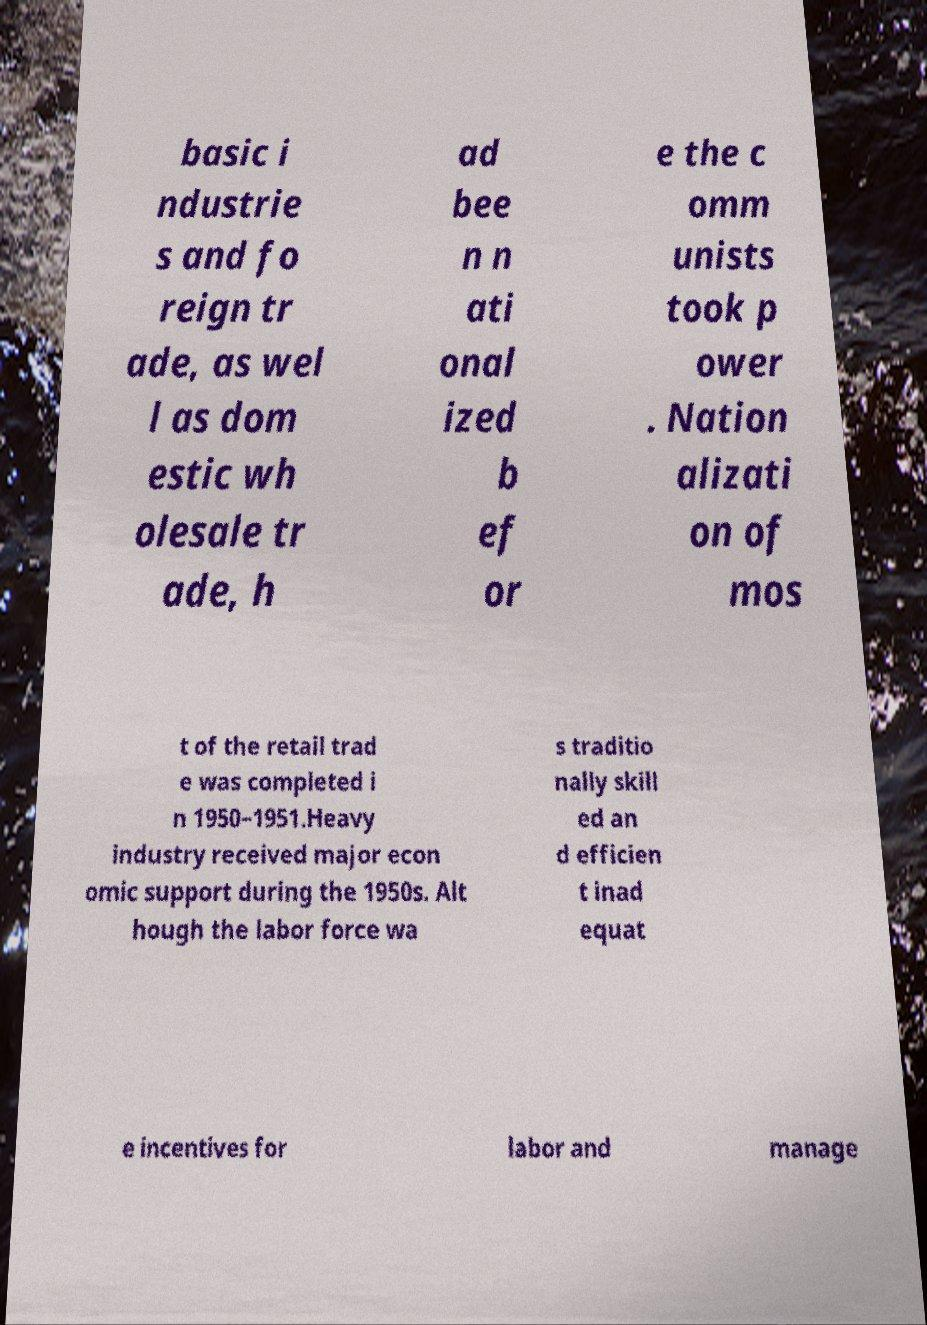Could you extract and type out the text from this image? basic i ndustrie s and fo reign tr ade, as wel l as dom estic wh olesale tr ade, h ad bee n n ati onal ized b ef or e the c omm unists took p ower . Nation alizati on of mos t of the retail trad e was completed i n 1950–1951.Heavy industry received major econ omic support during the 1950s. Alt hough the labor force wa s traditio nally skill ed an d efficien t inad equat e incentives for labor and manage 